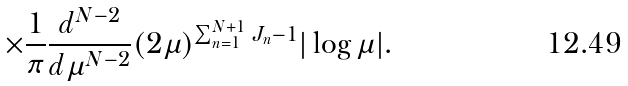<formula> <loc_0><loc_0><loc_500><loc_500>\times \frac { 1 } { \pi } \frac { d ^ { N - 2 } } { d \mu ^ { N - 2 } } ( 2 \mu ) ^ { \sum _ { n = 1 } ^ { N + 1 } J _ { n } - 1 } | \log \mu | .</formula> 